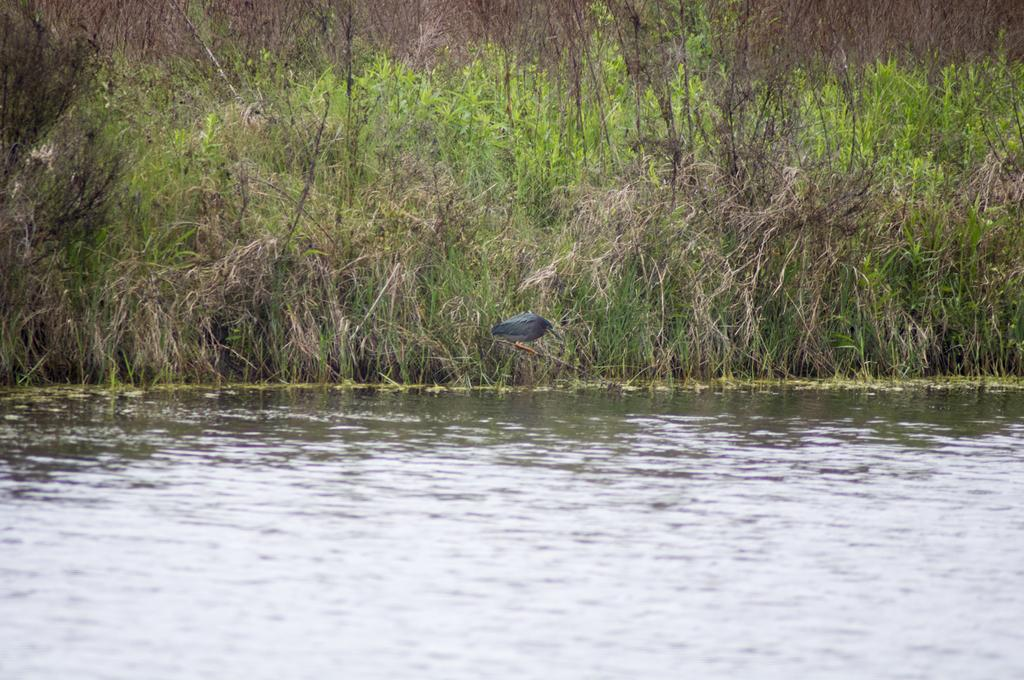What is the main feature of the image? There is a pond in the image. What can be seen in the pond? There is no information about what is in the pond. What is the bird doing in the image? The bird is standing on a stick in the image. Where is the stick located? The stick is on land covered with plants. What type of riddle is the bird trying to solve while standing on the stick? There is no indication in the image that the bird is trying to solve a riddle or engage in any activity other than standing on the stick. 